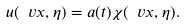Convert formula to latex. <formula><loc_0><loc_0><loc_500><loc_500>u ( \ v x , \eta ) = a ( t ) \chi ( \ v x , \eta ) .</formula> 